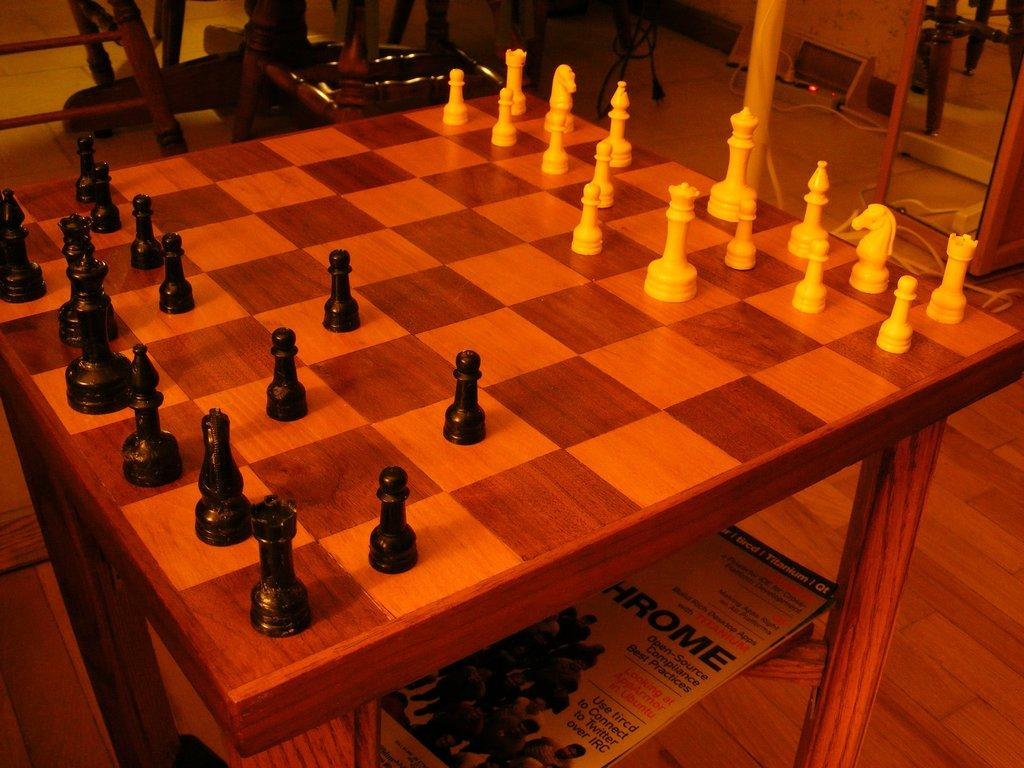What game is being played on the board in the image? There is a chess board in the image, suggesting that a game of chess is being played. What type of furniture is present in the image? There are chairs in the image. How does the chess board support itself in the image? The chess board does not support itself; it is likely placed on a table or another surface. 